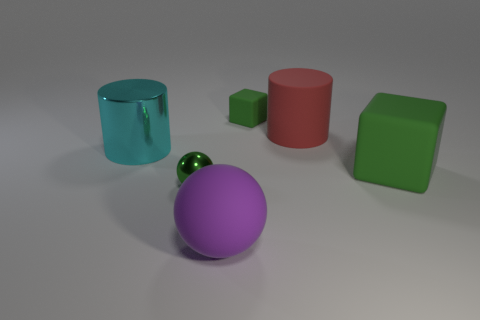Add 2 metallic cylinders. How many objects exist? 8 Subtract all cylinders. How many objects are left? 4 Subtract all brown cubes. Subtract all gray cylinders. How many cubes are left? 2 Subtract 0 cyan spheres. How many objects are left? 6 Subtract all big green blocks. Subtract all purple things. How many objects are left? 4 Add 5 small green balls. How many small green balls are left? 6 Add 2 tiny yellow metallic objects. How many tiny yellow metallic objects exist? 2 